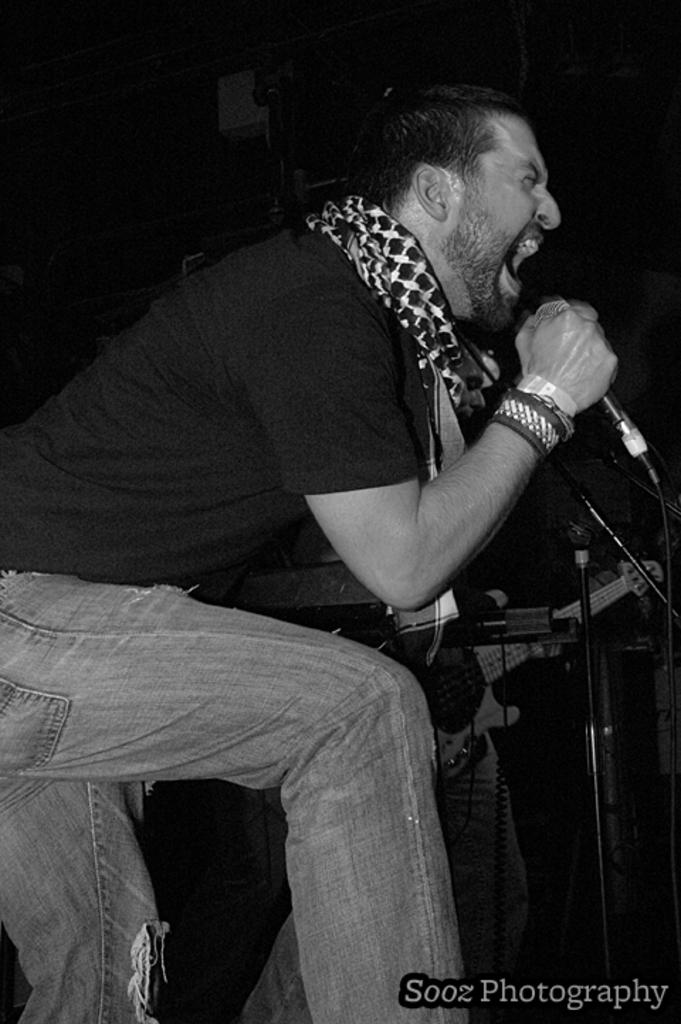What is the person in the image doing? The person is standing and appears to be singing, as they are holding a microphone. Can you describe the other person in the image? There is another person in the image, but their actions or role are not clear from the provided facts. What instrument is visible in the image? There is a guitar in the image. What type of bottle is being used to play the guitar in the image? There is no bottle present in the image, and the guitar is not being played with a bottle. 